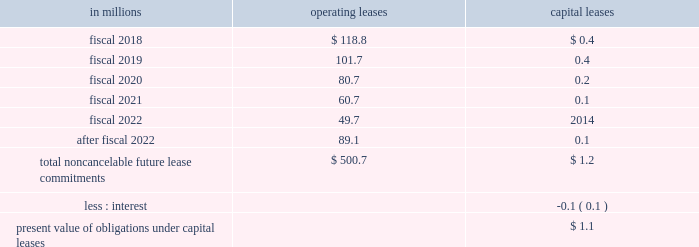Able to reasonably estimate the timing of future cash flows beyond 12 months due to uncertainties in the timing of tax audit outcomes .
The remaining amount of our unrecognized tax liability was classified in other liabilities .
We report accrued interest and penalties related to unrecognized tax benefit liabilities in income tax expense .
For fiscal 2017 , we recognized a net benefit of $ 5.6 million of tax-related net interest and penalties , and had $ 23.1 million of accrued interest and penalties as of may 28 , 2017 .
For fiscal 2016 , we recognized a net benefit of $ 2.7 million of tax-related net interest and penalties , and had $ 32.1 million of accrued interest and penalties as of may 29 , 2016 .
Note 15 .
Leases , other commitments , and contingencies the company 2019s leases are generally for warehouse space and equipment .
Rent expense under all operating leases from continuing operations was $ 188.1 million in fiscal 2017 , $ 189.1 million in fiscal 2016 , and $ 193.5 million in fiscal 2015 .
Some operating leases require payment of property taxes , insurance , and maintenance costs in addition to the rent payments .
Contingent and escalation rent in excess of minimum rent payments and sublease income netted in rent expense were insignificant .
Noncancelable future lease commitments are : operating capital in millions leases leases .
Depreciation on capital leases is recorded as deprecia- tion expense in our results of operations .
As of may 28 , 2017 , we have issued guarantees and comfort letters of $ 504.7 million for the debt and other obligations of consolidated subsidiaries , and guarantees and comfort letters of $ 165.3 million for the debt and other obligations of non-consolidated affiliates , mainly cpw .
In addition , off-balance sheet arrangements are generally limited to the future payments under non-cancelable operating leases , which totaled $ 500.7 million as of may 28 , 2017 .
Note 16 .
Business segment and geographic information we operate in the consumer foods industry .
In the third quarter of fiscal 2017 , we announced a new global orga- nization structure to streamline our leadership , enhance global scale , and drive improved operational agility to maximize our growth capabilities .
As a result of this global reorganization , beginning in the third quarter of fiscal 2017 , we reported results for our four operating segments as follows : north america retail , 65.3 percent of our fiscal 2017 consolidated net sales ; convenience stores & foodservice , 12.0 percent of our fiscal 2017 consolidated net sales ; europe & australia , 11.7 percent of our fiscal 2017 consolidated net sales ; and asia & latin america , 11.0 percent of our fiscal 2017 consoli- dated net sales .
We have restated our net sales by seg- ment and segment operating profit amounts to reflect our new operating segments .
These segment changes had no effect on previously reported consolidated net sales , operating profit , net earnings attributable to general mills , or earnings per share .
Our north america retail operating segment consists of our former u.s .
Retail operating units and our canada region .
Within our north america retail operating seg- ment , our former u.s .
Meals operating unit and u.s .
Baking operating unit have been combined into one operating unit : u.s .
Meals & baking .
Our convenience stores & foodservice operating segment is unchanged .
Our europe & australia operating segment consists of our former europe region .
Our asia & latin america operating segment consists of our former asia/pacific and latin america regions .
Under our new organization structure , our chief operating decision maker assesses performance and makes decisions about resources to be allocated to our segments at the north america retail , convenience stores & foodservice , europe & australia , and asia & latin america operating segment level .
Our north america retail operating segment reflects business with a wide variety of grocery stores , mass merchandisers , membership stores , natural food chains , drug , dollar and discount chains , and e-commerce gro- cery providers .
Our product categories in this business 84 general mills .
In 2017 what was the percent of the total non-cancelable future lease commitments are for operating leases that was due in 2018? 
Computations: (118.8 / 500.7)
Answer: 0.23727. 